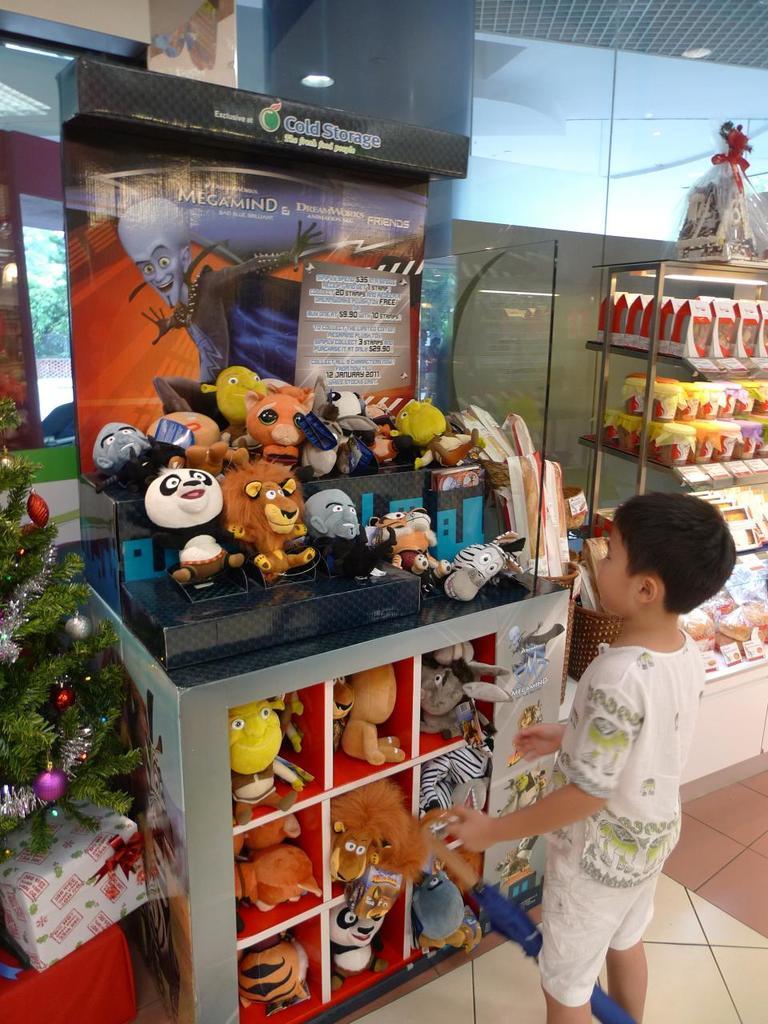Please provide a concise description of this image. In the center of the image we can see one kid is standing and he is holding some object. In the background there is a wall, glass, racks, toys, gift boxes, one Xmas tree and a few other objects. 